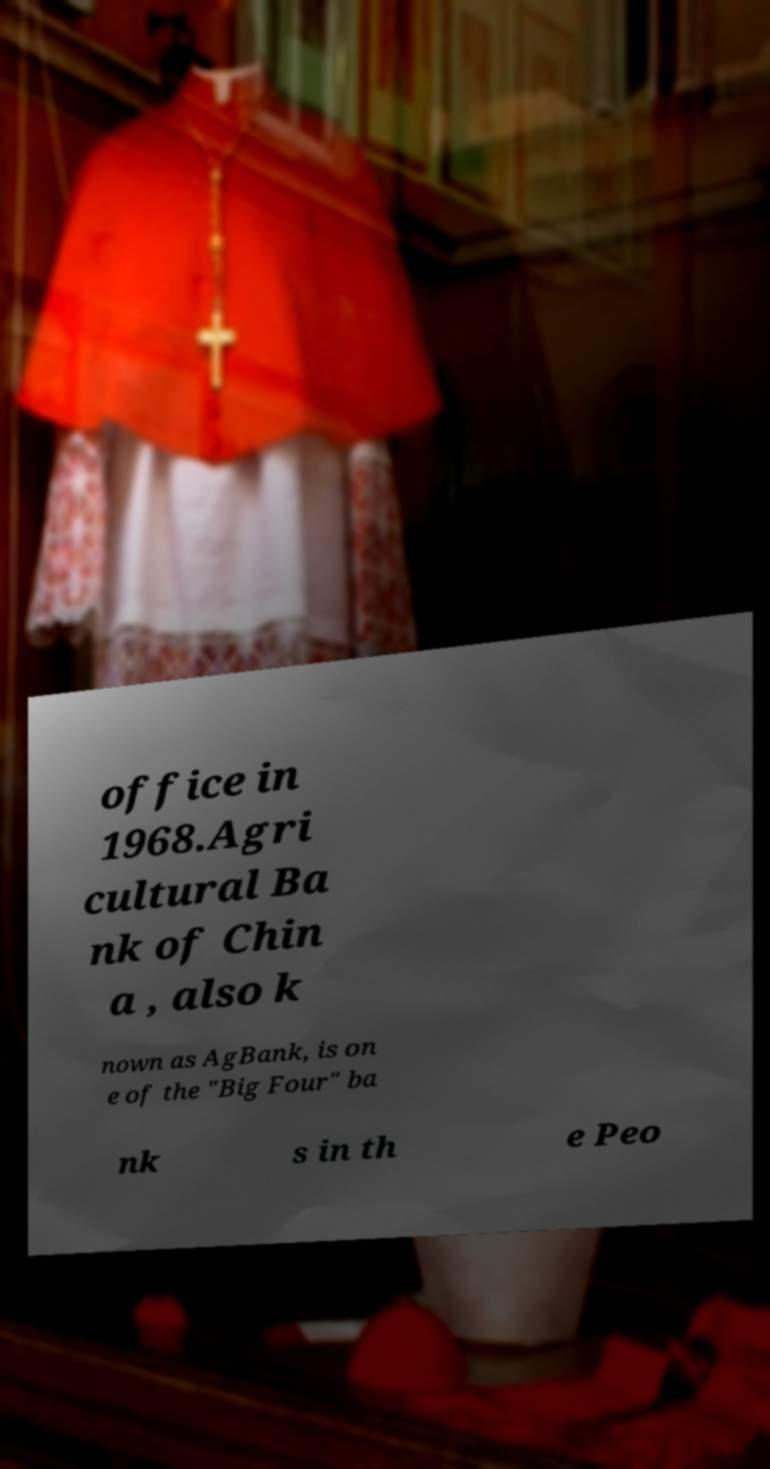Can you read and provide the text displayed in the image?This photo seems to have some interesting text. Can you extract and type it out for me? office in 1968.Agri cultural Ba nk of Chin a , also k nown as AgBank, is on e of the "Big Four" ba nk s in th e Peo 